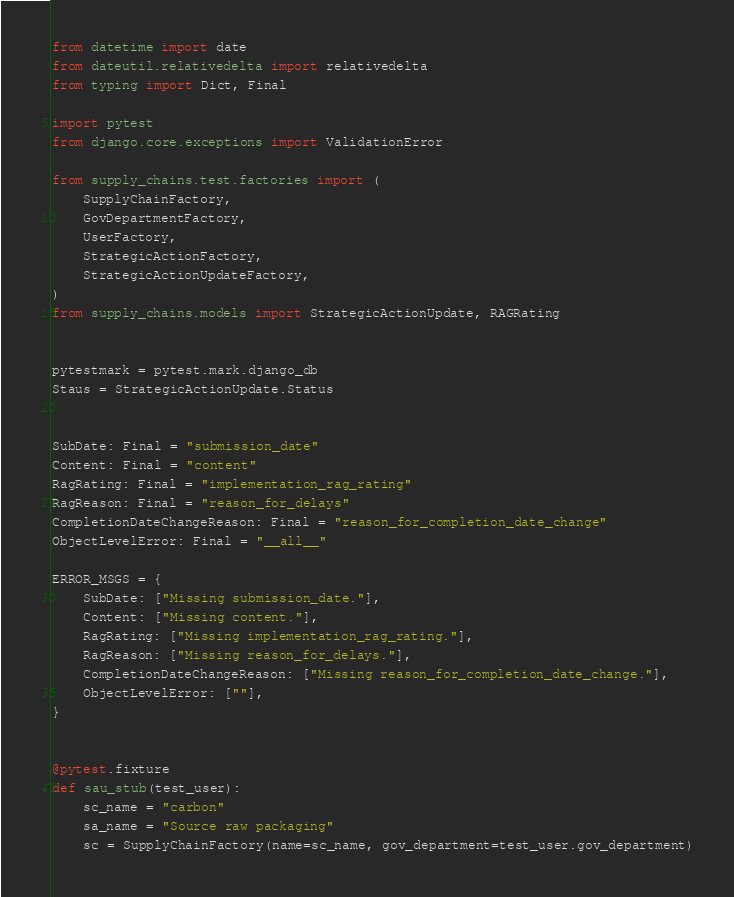<code> <loc_0><loc_0><loc_500><loc_500><_Python_>from datetime import date
from dateutil.relativedelta import relativedelta
from typing import Dict, Final

import pytest
from django.core.exceptions import ValidationError

from supply_chains.test.factories import (
    SupplyChainFactory,
    GovDepartmentFactory,
    UserFactory,
    StrategicActionFactory,
    StrategicActionUpdateFactory,
)
from supply_chains.models import StrategicActionUpdate, RAGRating


pytestmark = pytest.mark.django_db
Staus = StrategicActionUpdate.Status


SubDate: Final = "submission_date"
Content: Final = "content"
RagRating: Final = "implementation_rag_rating"
RagReason: Final = "reason_for_delays"
CompletionDateChangeReason: Final = "reason_for_completion_date_change"
ObjectLevelError: Final = "__all__"

ERROR_MSGS = {
    SubDate: ["Missing submission_date."],
    Content: ["Missing content."],
    RagRating: ["Missing implementation_rag_rating."],
    RagReason: ["Missing reason_for_delays."],
    CompletionDateChangeReason: ["Missing reason_for_completion_date_change."],
    ObjectLevelError: [""],
}


@pytest.fixture
def sau_stub(test_user):
    sc_name = "carbon"
    sa_name = "Source raw packaging"
    sc = SupplyChainFactory(name=sc_name, gov_department=test_user.gov_department)</code> 